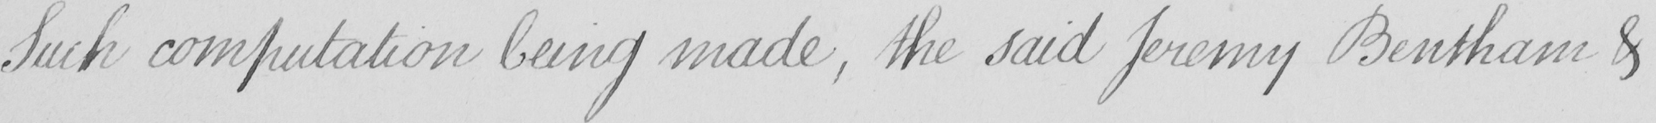What is written in this line of handwriting? Such computation being made , the said Jeremy Bentham & 